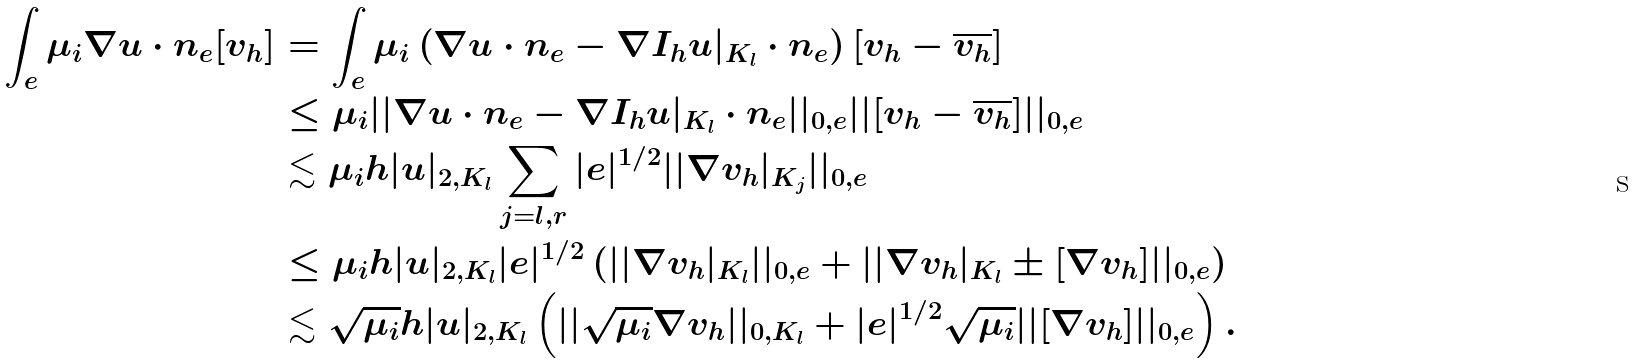<formula> <loc_0><loc_0><loc_500><loc_500>\int _ { e } \mu _ { i } \nabla u \cdot n _ { e } [ v _ { h } ] & = \int _ { e } \mu _ { i } \left ( \nabla u \cdot n _ { e } - \nabla { I _ { h } u } | _ { K _ { l } } \cdot n _ { e } \right ) [ v _ { h } - \overline { v _ { h } } ] \\ & \leq \mu _ { i } | | \nabla u \cdot n _ { e } - \nabla { I _ { h } u } | _ { K _ { l } } \cdot n _ { e } | | _ { 0 , e } | | [ v _ { h } - \overline { v _ { h } } ] | | _ { 0 , e } \\ & \lesssim \mu _ { i } h | u | _ { 2 , K _ { l } } \sum _ { j = l , r } | e | ^ { 1 / 2 } | | { \nabla v _ { h } } | _ { K _ { j } } | | _ { 0 , e } \\ & \leq \mu _ { i } h | u | _ { 2 , K _ { l } } | e | ^ { 1 / 2 } \left ( | | { \nabla v _ { h } } | _ { K _ { l } } | | _ { 0 , e } + | | { \nabla v _ { h } } | _ { K _ { l } } \pm [ \nabla v _ { h } ] | | _ { 0 , e } \right ) \\ & \lesssim \sqrt { \mu _ { i } } h | u | _ { 2 , K _ { l } } \left ( | | \sqrt { \mu _ { i } } { \nabla v _ { h } } | | _ { 0 , K _ { l } } + | e | ^ { 1 / 2 } \sqrt { \mu _ { i } } | | [ \nabla v _ { h } ] | | _ { 0 , e } \right ) .</formula> 